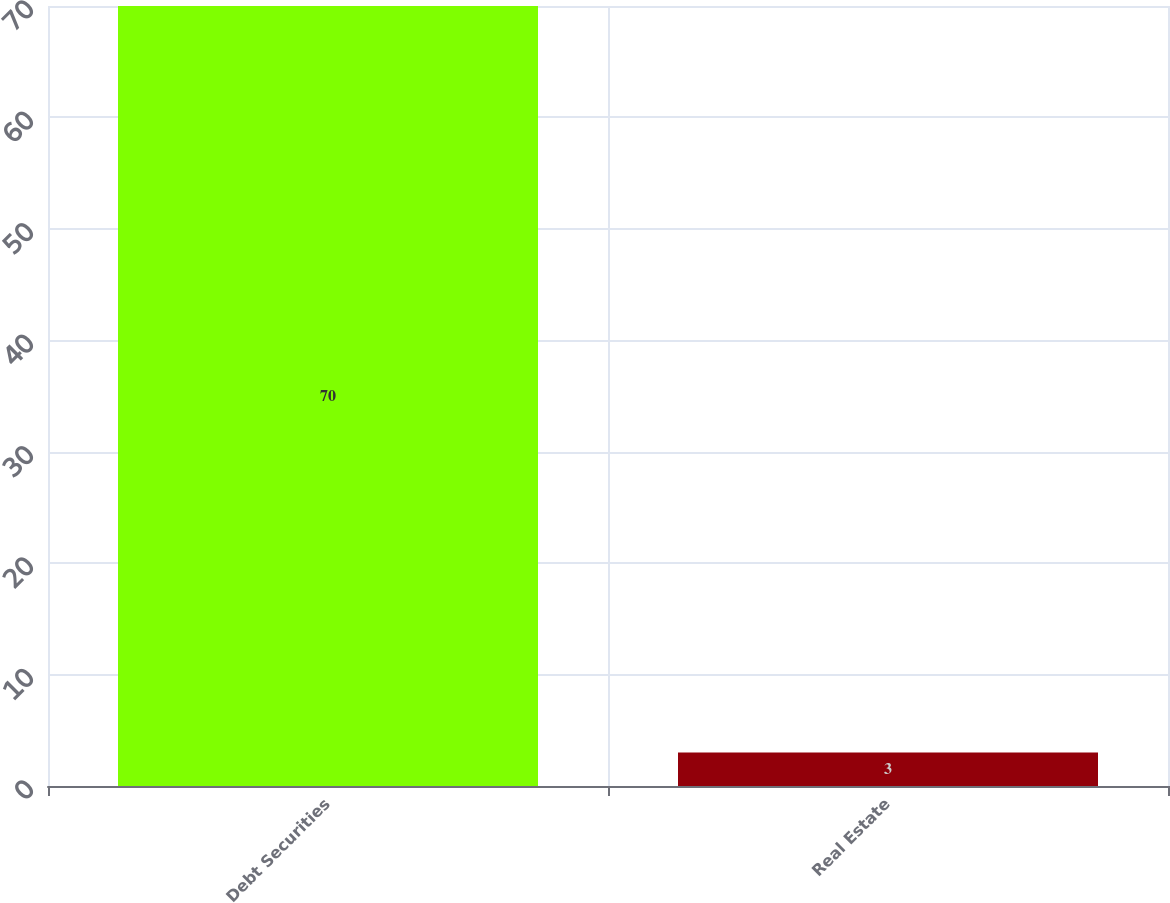Convert chart to OTSL. <chart><loc_0><loc_0><loc_500><loc_500><bar_chart><fcel>Debt Securities<fcel>Real Estate<nl><fcel>70<fcel>3<nl></chart> 